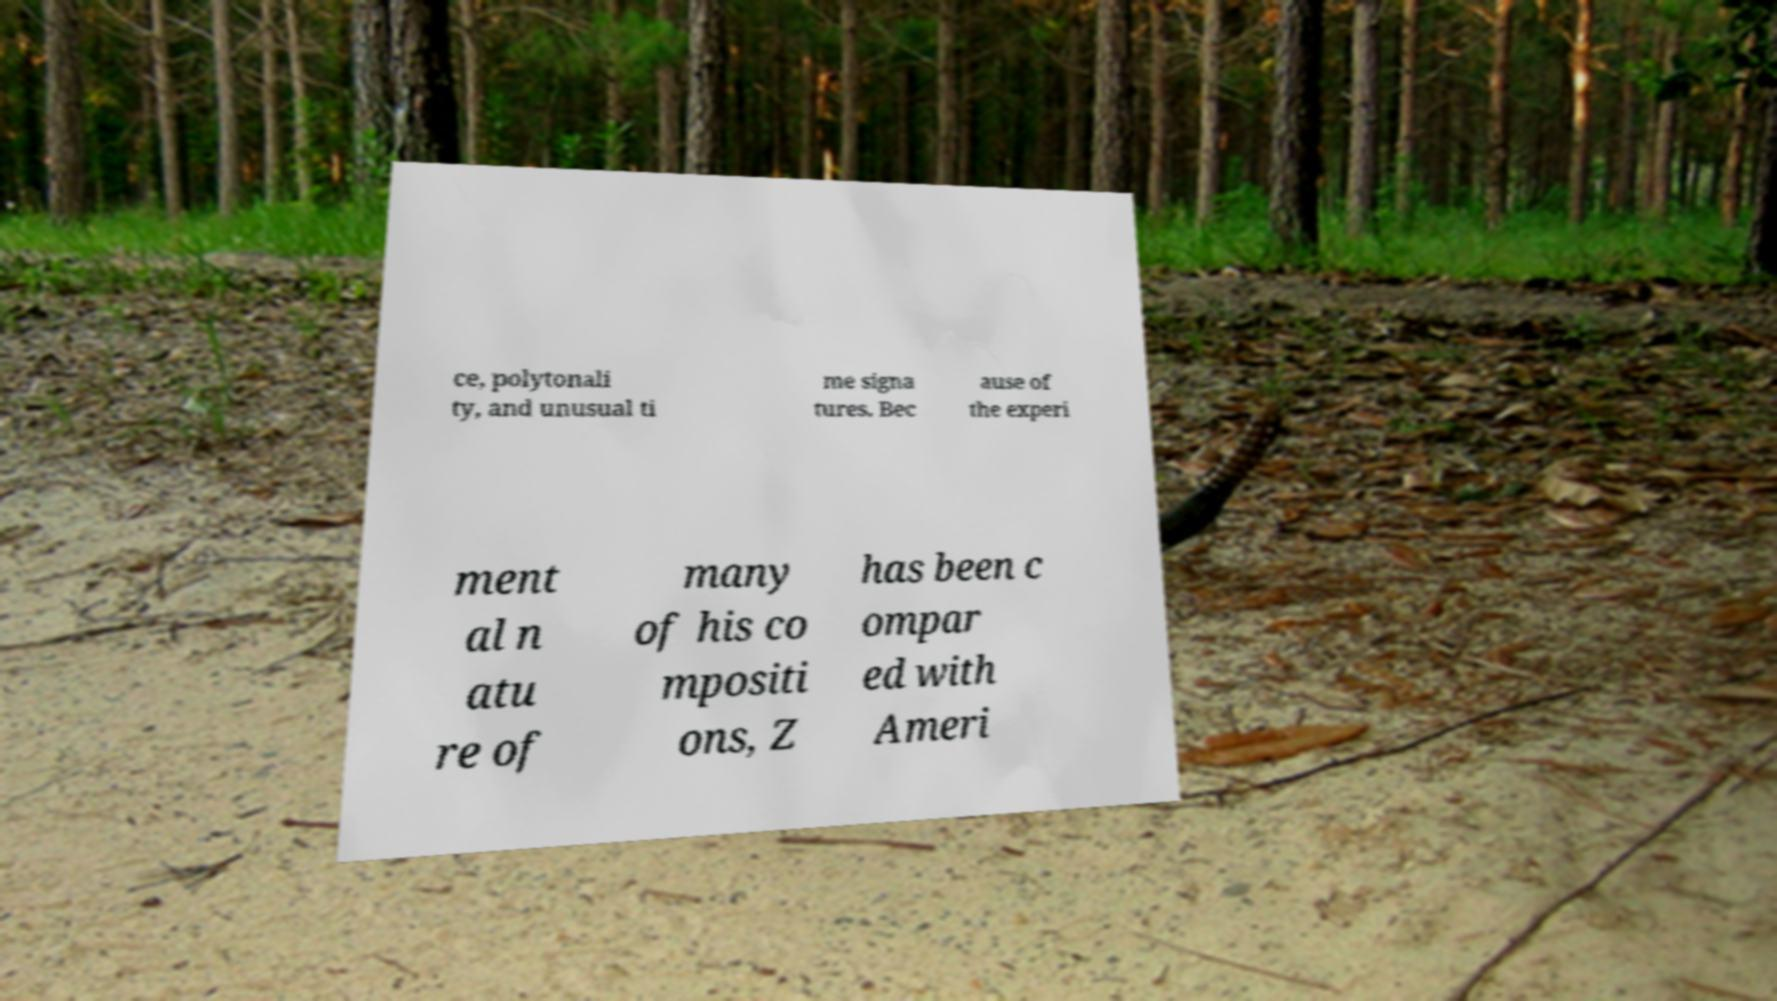I need the written content from this picture converted into text. Can you do that? ce, polytonali ty, and unusual ti me signa tures. Bec ause of the experi ment al n atu re of many of his co mpositi ons, Z has been c ompar ed with Ameri 